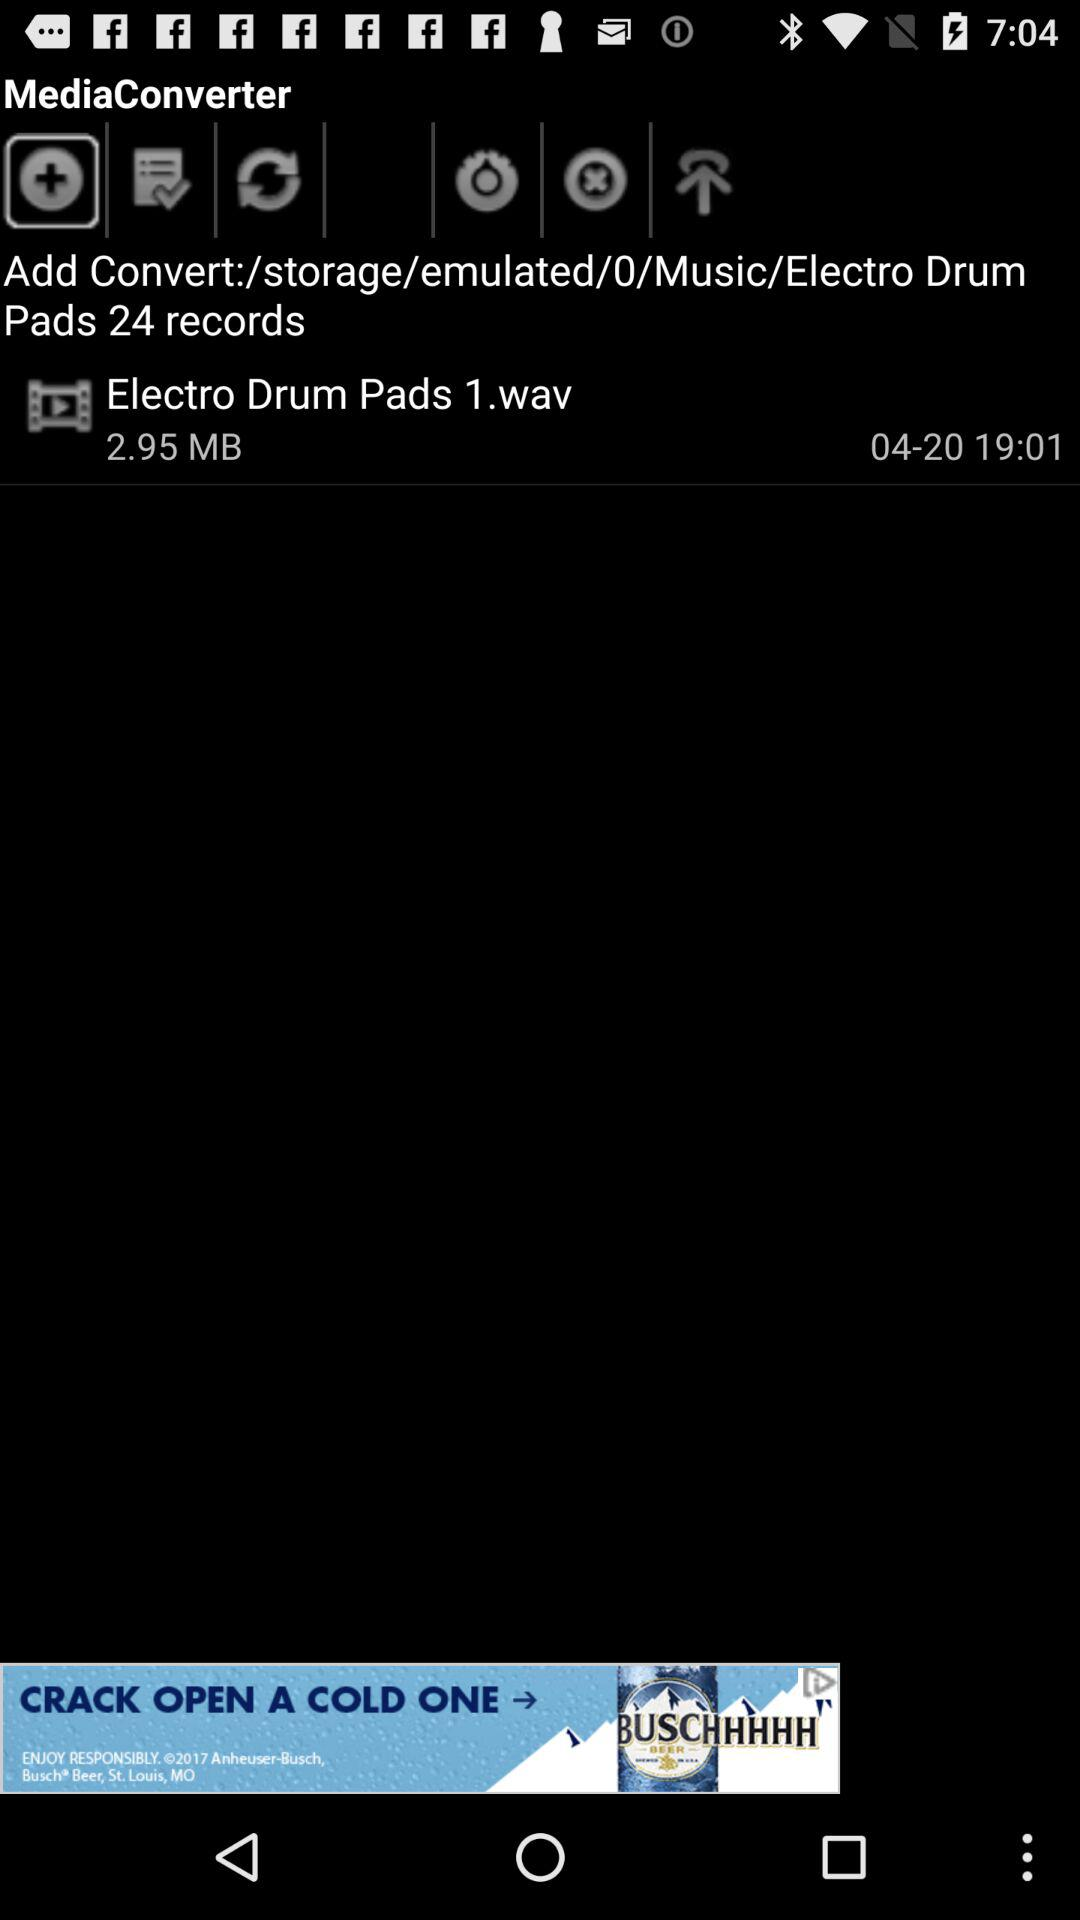What is the time? The time is 19:01. 